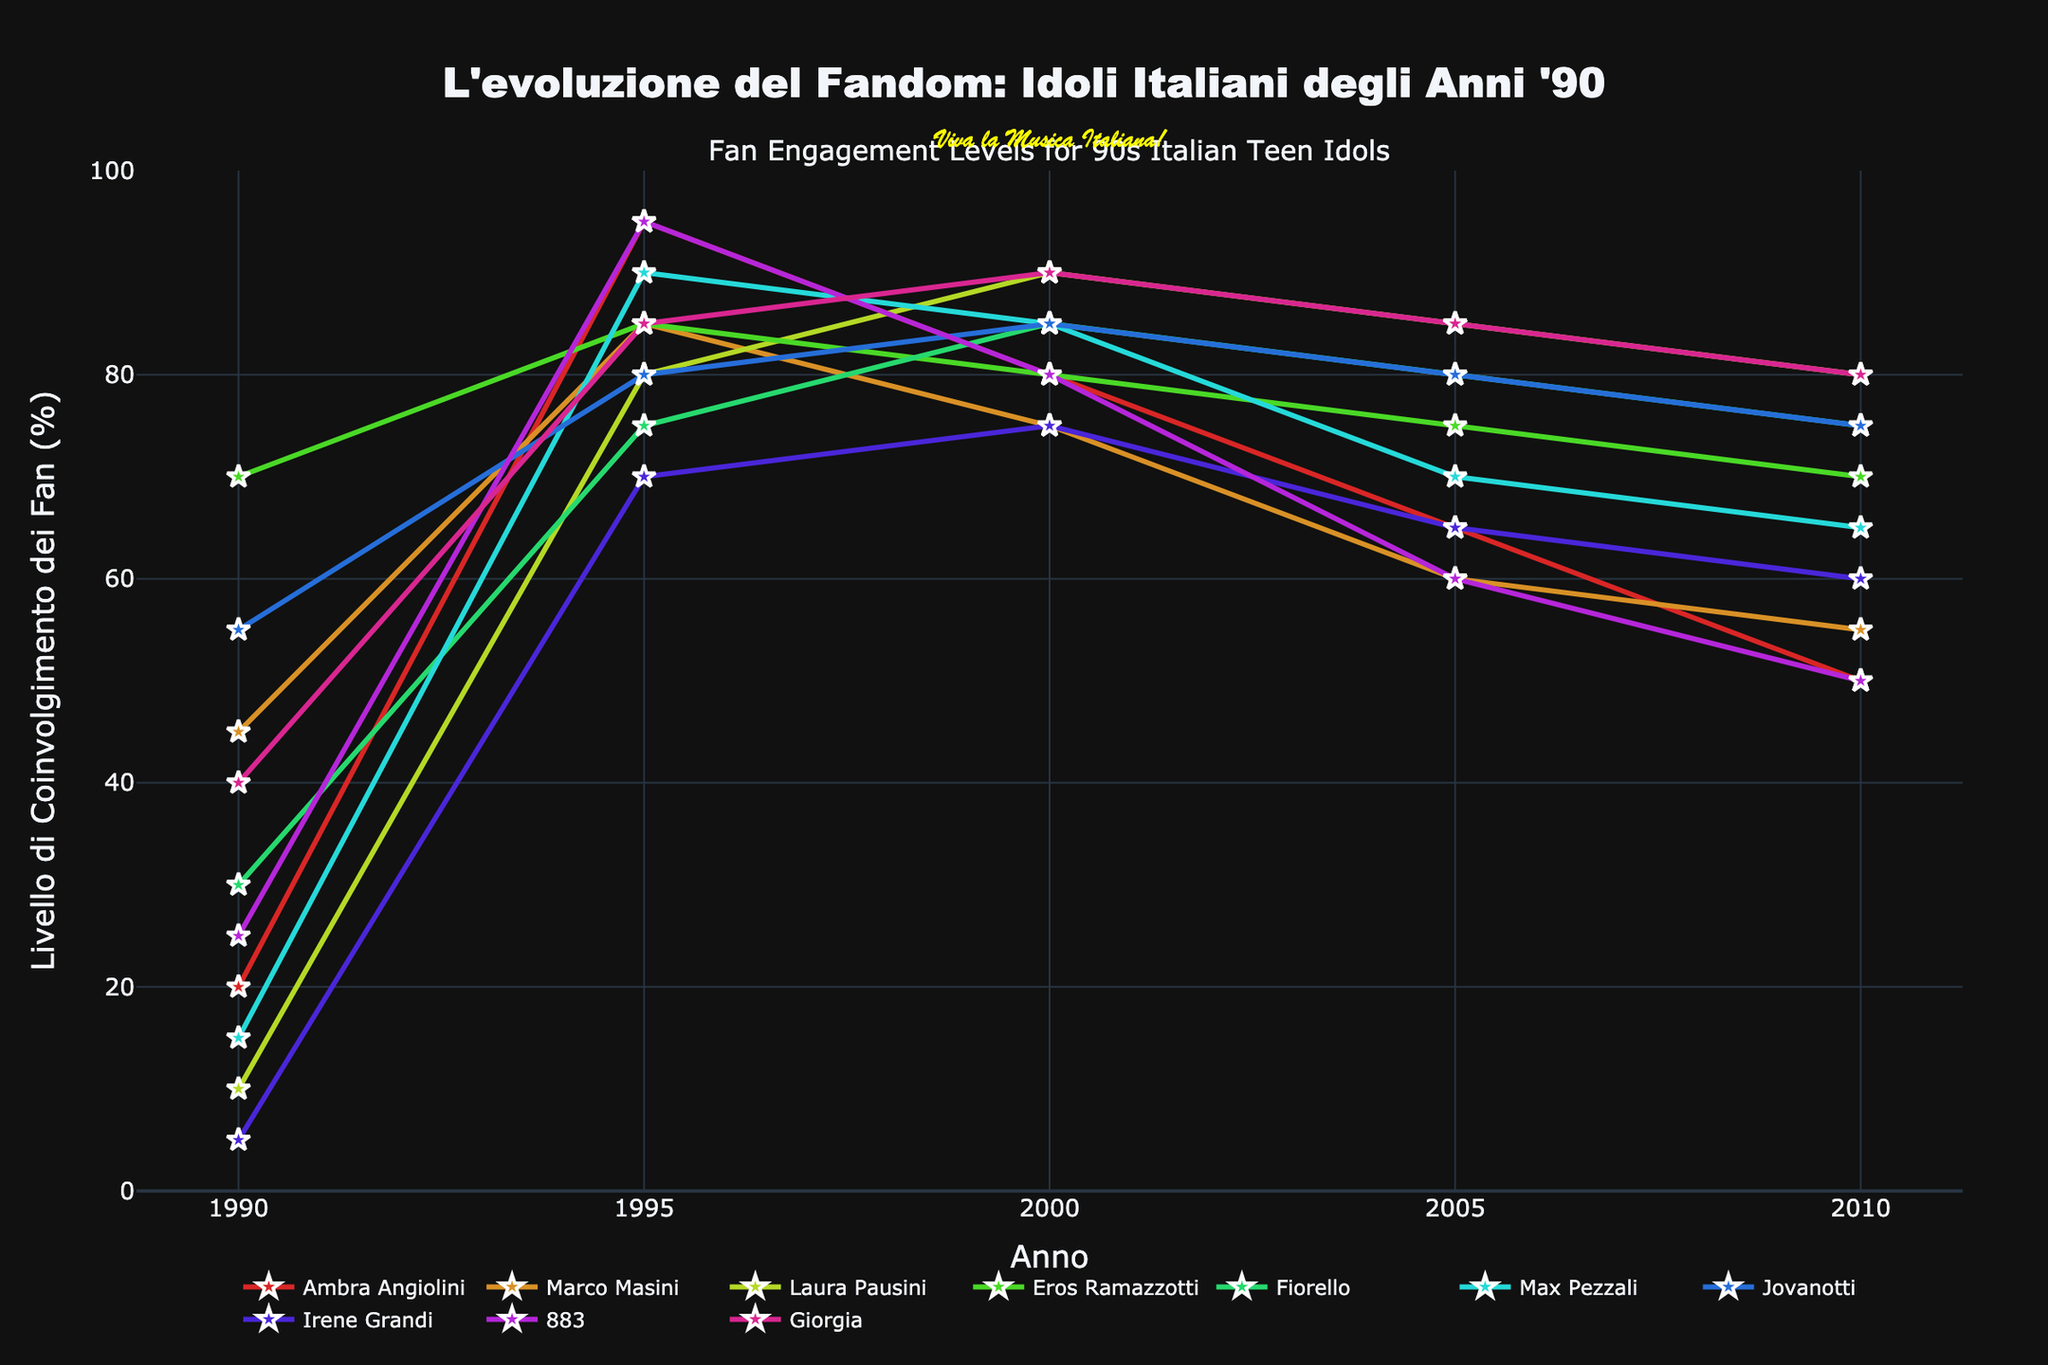What's the title of the chart? The title of the chart is located at the top and often provides a concise summary of the data being presented. It is written in large, bold text, which is easily recognizable.
Answer: L'evoluzione del Fandom: Idoli Italiani degli Anni '90 Which artist had the highest fan engagement in 1995? To find this, locate the year 1995 on the X-axis and then check the corresponding Y-values for each artist. The artist with the highest Y-value is the one with the highest fan engagement.
Answer: Ambra Angiolini and 883 Whose fan engagement levels consistently increased from 1990 to 2000? Examine the lines of each artist from 1990 to 2000. Only those that show a consistent upward trend throughout this period fit this criterion.
Answer: Laura Pausini and Fiorello What is the average fan engagement of Eros Ramazzotti over the period? Sum up the fan engagement values of Eros Ramazzotti for each year listed (70, 85, 80, 75, 70) and divide by the number of years (5) to get the average.
Answer: 76 Who had a drop in fan engagement between 2000 and 2010 and by how much? Find the fan engagement values for 2000 and 2010 for each artist, then compute the difference. The artist with a drop has a negative difference.
Answer: 883, 30 Among all artists, who had the most significant peak in fan engagement and when? Locate the maximum values for each artist and identify the highest among them. Note the year when this peak occurs.
Answer: Ambra Angiolini, 1995 Which two artists had the same fan engagement level in 2010? Look at the fan engagement levels for all artists in 2010 and identify any that share the same value.
Answer: Laura Pausini and Giorgia What is the average fan engagement level across all artists in the year 2000? Add up the fan engagement values for all the artists in 2000 and then divide by the total number of artists (10).
Answer: 82.5 Who had a steady decline in fan engagement from 1995 to 2010? Observe the trends from 1995 to 2010. Identify artists whose fan engagement consistently decreased during this period.
Answer: Max Pezzali and 883 Which artist showed the least variation in fan engagement levels over the entire period? Check the range of values (difference between the highest and lowest) for each artist. The artist with the smallest range had the least variation.
Answer: Jovanotti 